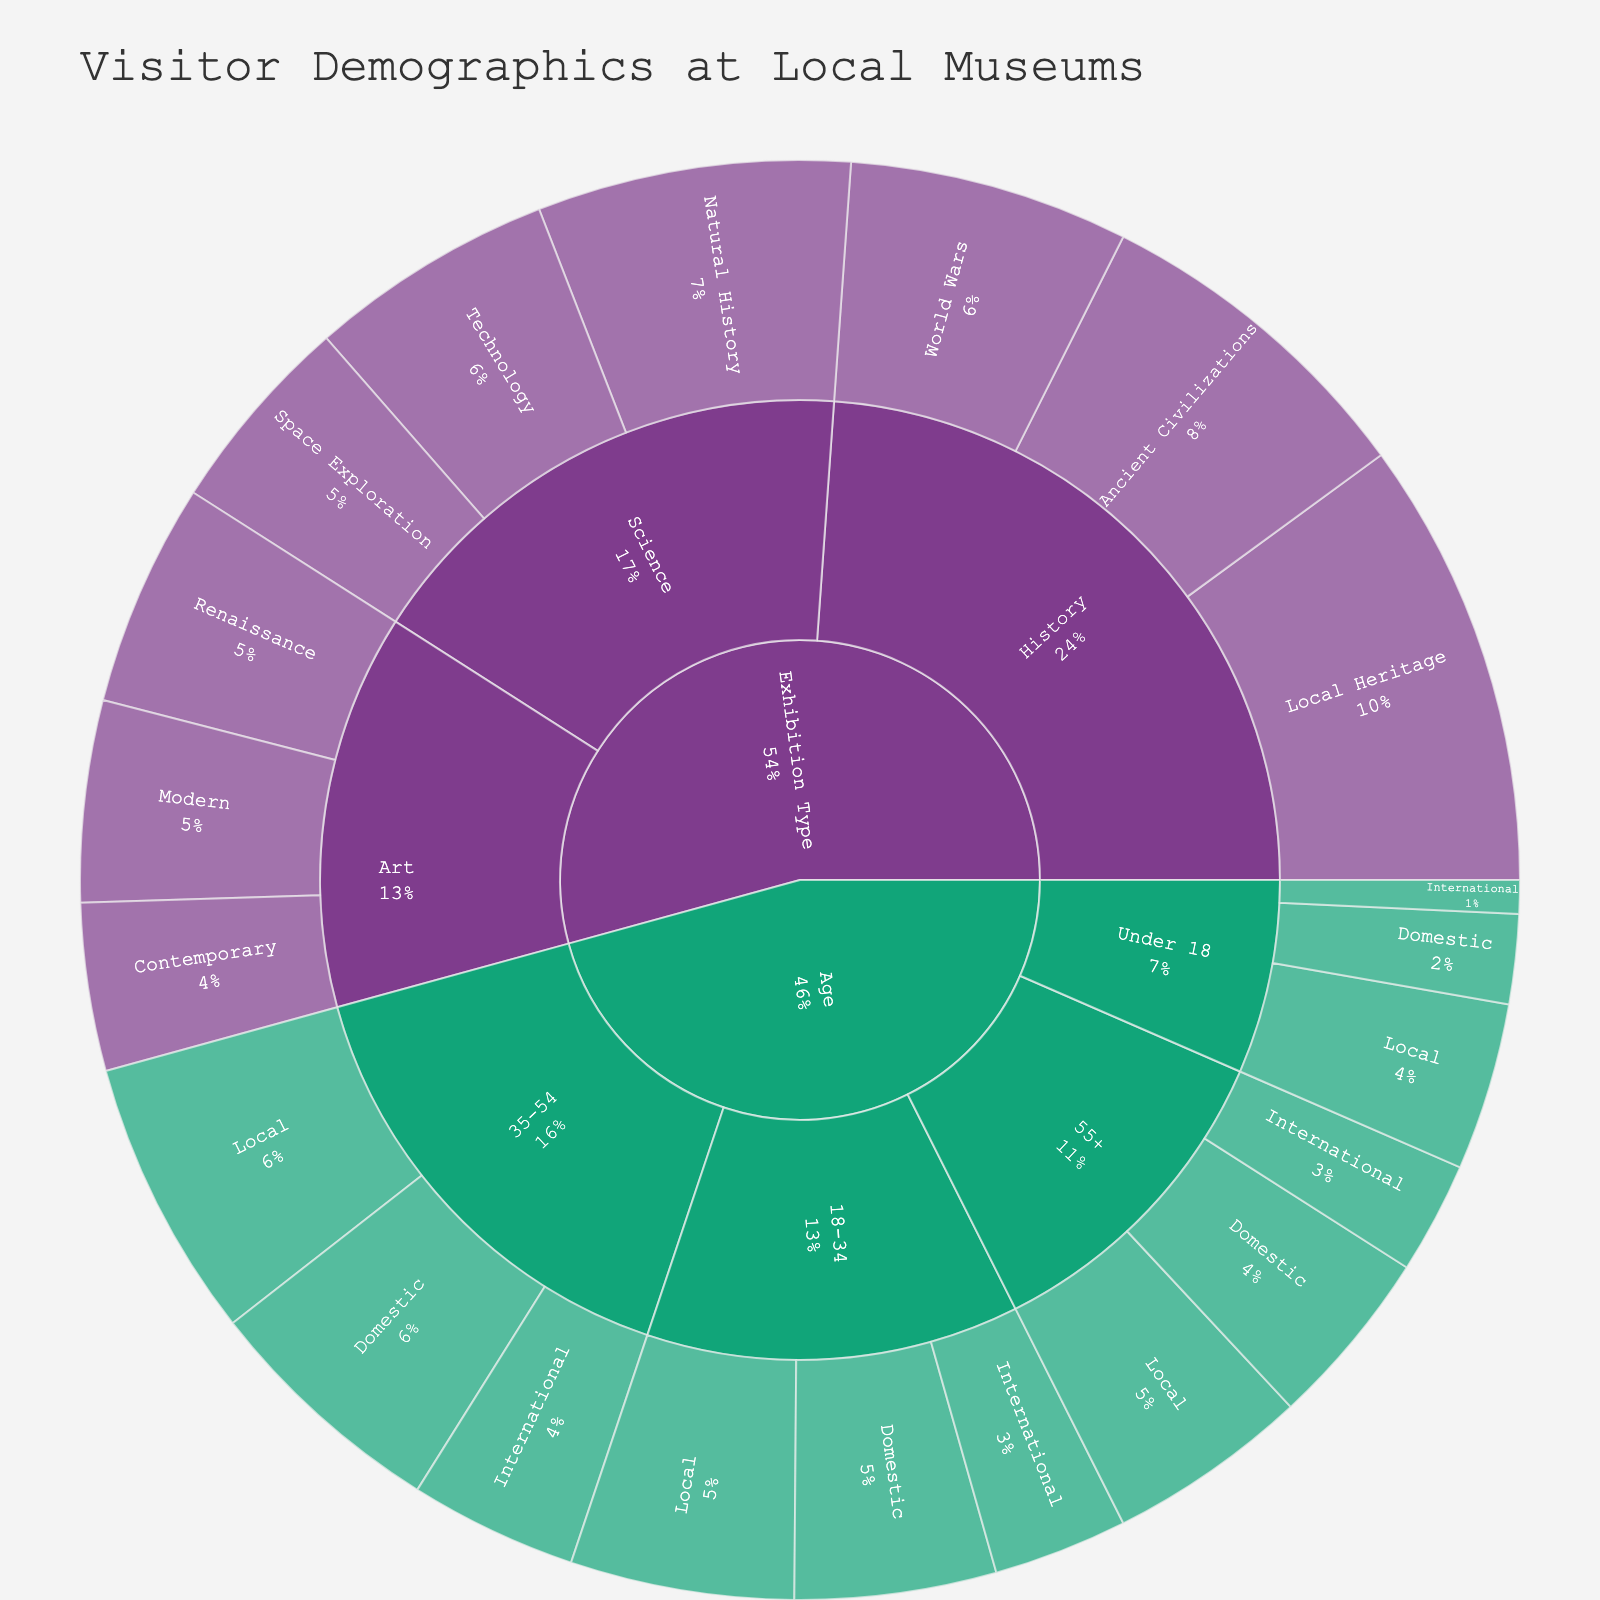What's the title of the figure? The title is usually placed at the top of the figure. Here, it reads "Visitor Demographics at Local Museums".
Answer: Visitor Demographics at Local Museums What's the total number of under 18 local visitors? To find this, look at the "Under 18" within the "Age" category and then the "Local" subcategory under it. The number is 150.
Answer: 150 Which age group has the highest number of visitors? Sum up the visitors in each age group: Under 18 (150 + 80 + 30 = 260), 18-34 (200 + 180 + 120 = 500), 35-54 (250 + 220 + 150 = 620), 55+ (180 + 160 + 100 = 440). The group 35-54 has the highest total of 620.
Answer: 35-54 What percentage of total visitors are aged 18-34 and are international? The total visitors for the age group 18-34 is 500, and among them, 120 are international. Thus, (120 / 500) * 100 gives the percentage.
Answer: 24% Which exhibition type has the largest number of visitors? Sum up the visitors in each exhibition type: History (300 + 400 + 250 = 950), Art (200 + 180 + 150 = 530), Science (280 + 220 + 180 = 680). History has the largest number of visitors.
Answer: History Compare the number of local visitors to the Modern Art exhibition and the Space Exploration exhibition. Which one is higher? Find the relevant numbers: Modern Art (180 under Art), Space Exploration (180 under Science). Both are equal.
Answer: Equal What is the total number of visitors to the Local Heritage exhibition? Look within the "History" category and then the "Local Heritage" subcategory. The number is 400.
Answer: 400 How does the number of visitors to Ancient Civilizations compare with Contemporary Art? Ancient Civilizations has 300 visitors, and Contemporary Art has 150. Therefore, Ancient Civilizations has more visitors.
Answer: Ancient Civilizations What is the total number of visitors from all categories combined? Sum up all the given values: 150+80+30+200+180+120+250+220+150+180+160+100+300+400+250+200+180+150+280+220+180 = 4280.
Answer: 4280 Which nationality has the fewest visitors aged under 18? Check the subcategories under under 18. Local (150), Domestic (80), International (30). International has the fewest.
Answer: International 